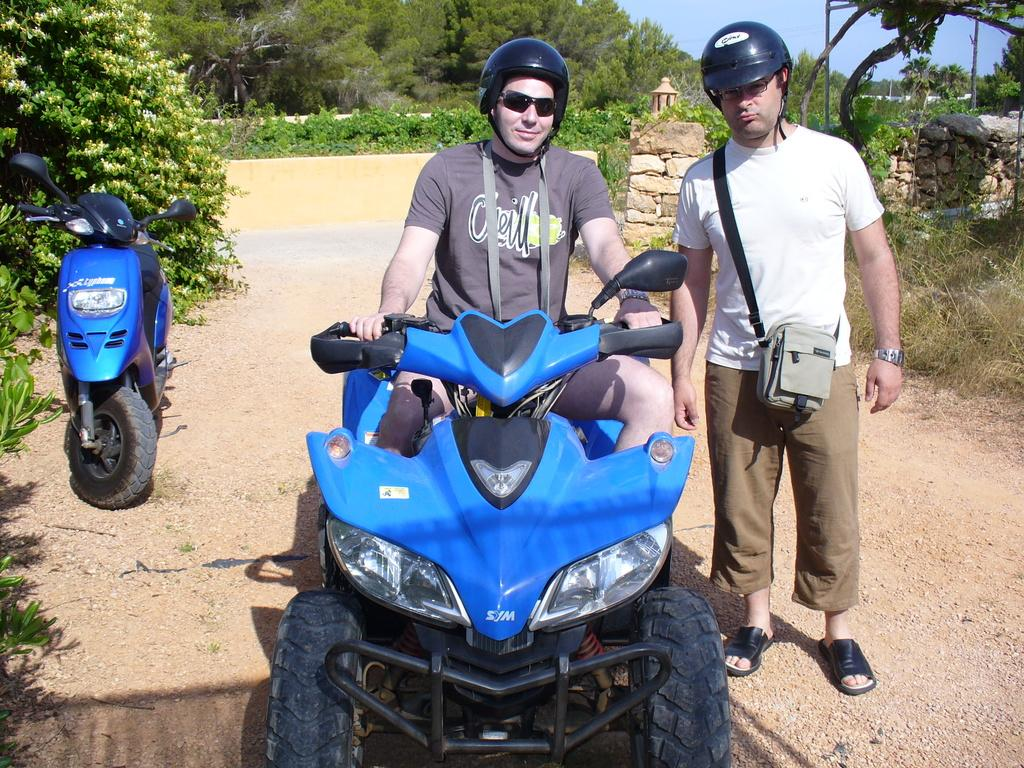What is the person in the image wearing on their head? The person in the image is wearing a helmet. What is the person doing while wearing the helmet? The person is sitting on a vehicle. Can you describe the other person in the image? There is another person in the image, but their actions or appearance are not specified. What type of vehicle is the person sitting on? The facts provided do not specify the type of vehicle, only that it is a vehicle. What can be seen in the background of the image? There are trees and plants in the image. What type of fireman is the person in the image? There is no mention of a fireman in the image. --- Facts: 1. There is a person in the image. 2. The person is holding a book. 3. The book has a blue cover. 4. The person is sitting on a chair. 5. There is a table next to the person. 6. There is a lamp on the table. Absurd Topics: unicorn, rainbow, magic wand Conversation: Who or what is in the image? There is a person in the image. What is the person holding? The person is holding a book. Can you describe the book? The book has a blue cover. What is the person's seating arrangement? The person is sitting on a chair. Is there any furniture near the person? Yes, there is a table next to the person. Are there any objects on the table? Yes, there is a lamp on the table. Reasoning: Let's think step by step in order to produce the conversation. We start by identifying the main subject in the image, which is the person. Then, we describe the actions of the person, noting that they are holding a book. Next, we observe the details of the book, such as the color of its cover. After that, we focus on the person's seating arrangement, mentioning that they are sitting on a chair. Then, we describe the presence of any furniture near the person, which in this case is a table. Finally, we mention any objects on the table, which is a lamp. Absurd Question/Answer: Can you see a unicorn in the image? No, there is no unicorn present in the image. 